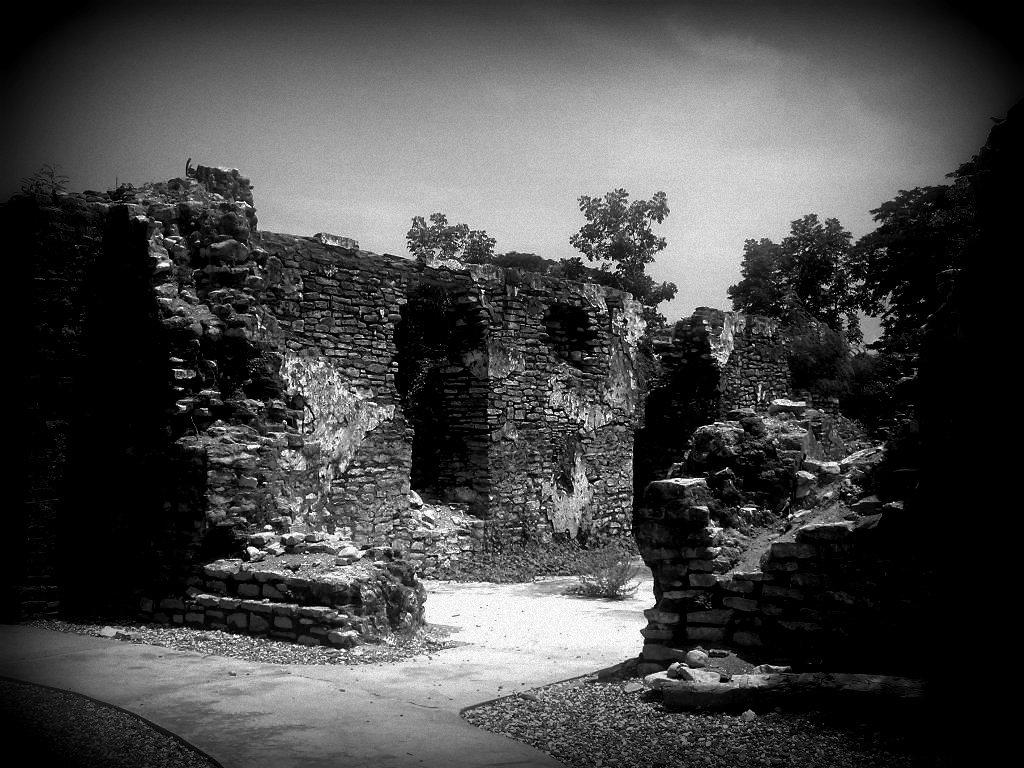What type of structure can be seen in the image? There are walls in the image. What type of vegetation is present in the image? There is a plant in the image, and trees are visible behind the walls. What is visible at the top of the image? The sky is visible at the top of the image. What can be found at the bottom of the image? There is a group of stones at the bottom of the image. Where is the spoon used to scoop honey from the icicle in the image? There is no spoon, honey, or icicle present in the image. 